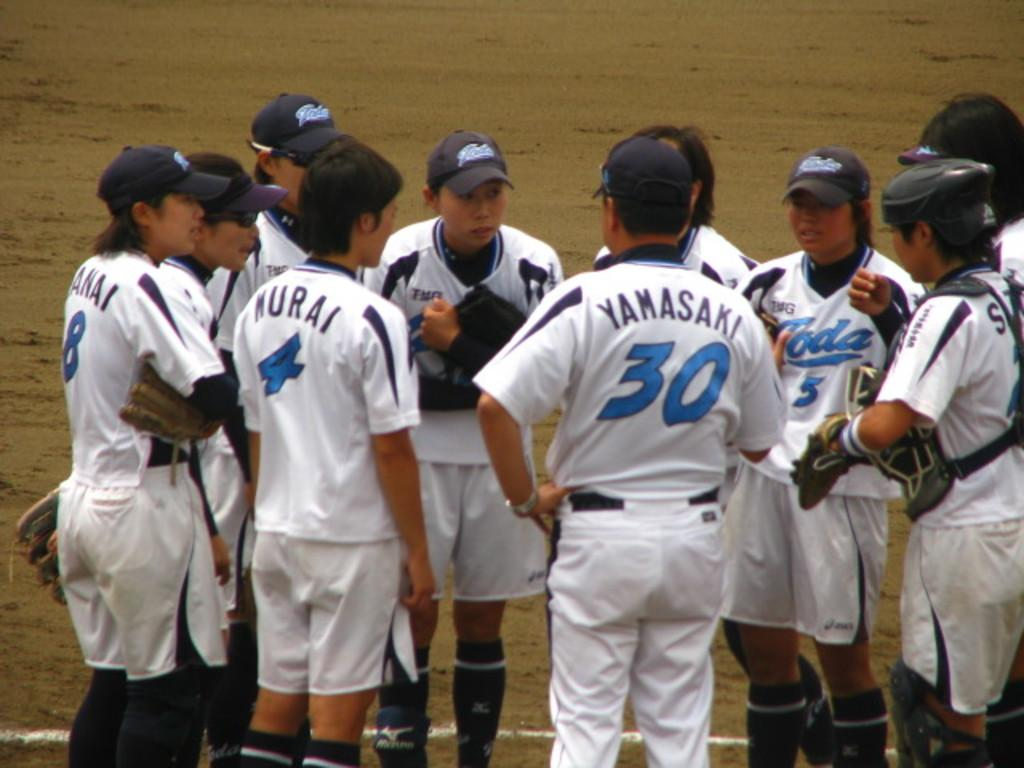<image>
Share a concise interpretation of the image provided. The athletic player Yamasaki is surrounded by his teammates on the playing field.. 